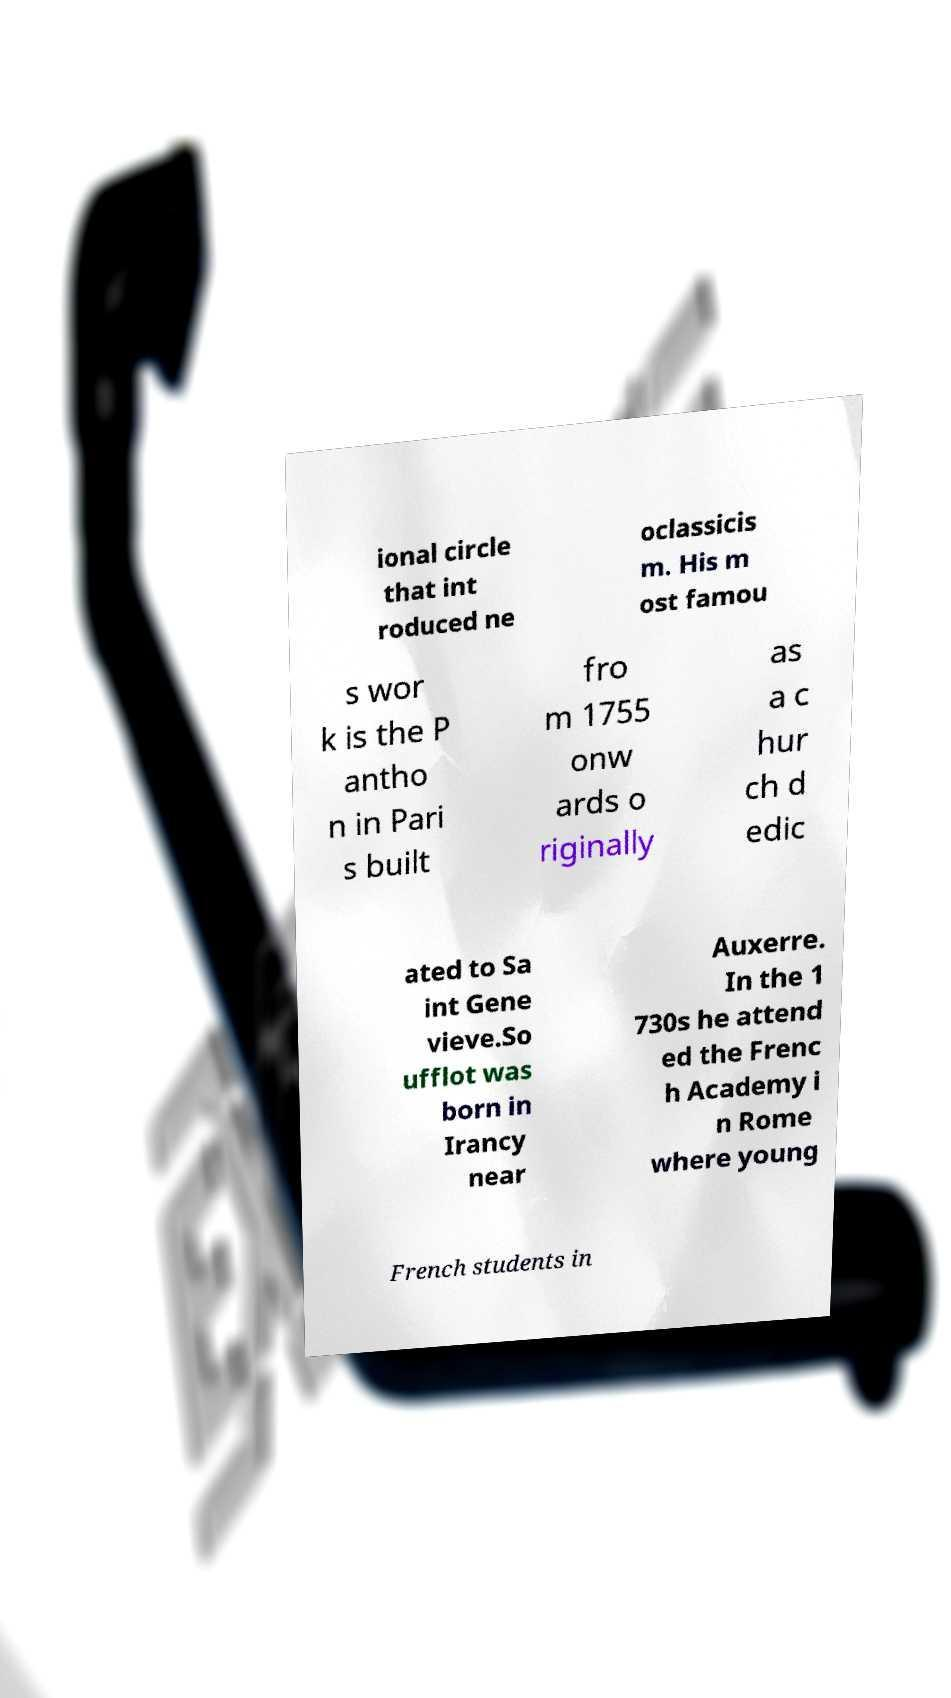Please identify and transcribe the text found in this image. ional circle that int roduced ne oclassicis m. His m ost famou s wor k is the P antho n in Pari s built fro m 1755 onw ards o riginally as a c hur ch d edic ated to Sa int Gene vieve.So ufflot was born in Irancy near Auxerre. In the 1 730s he attend ed the Frenc h Academy i n Rome where young French students in 